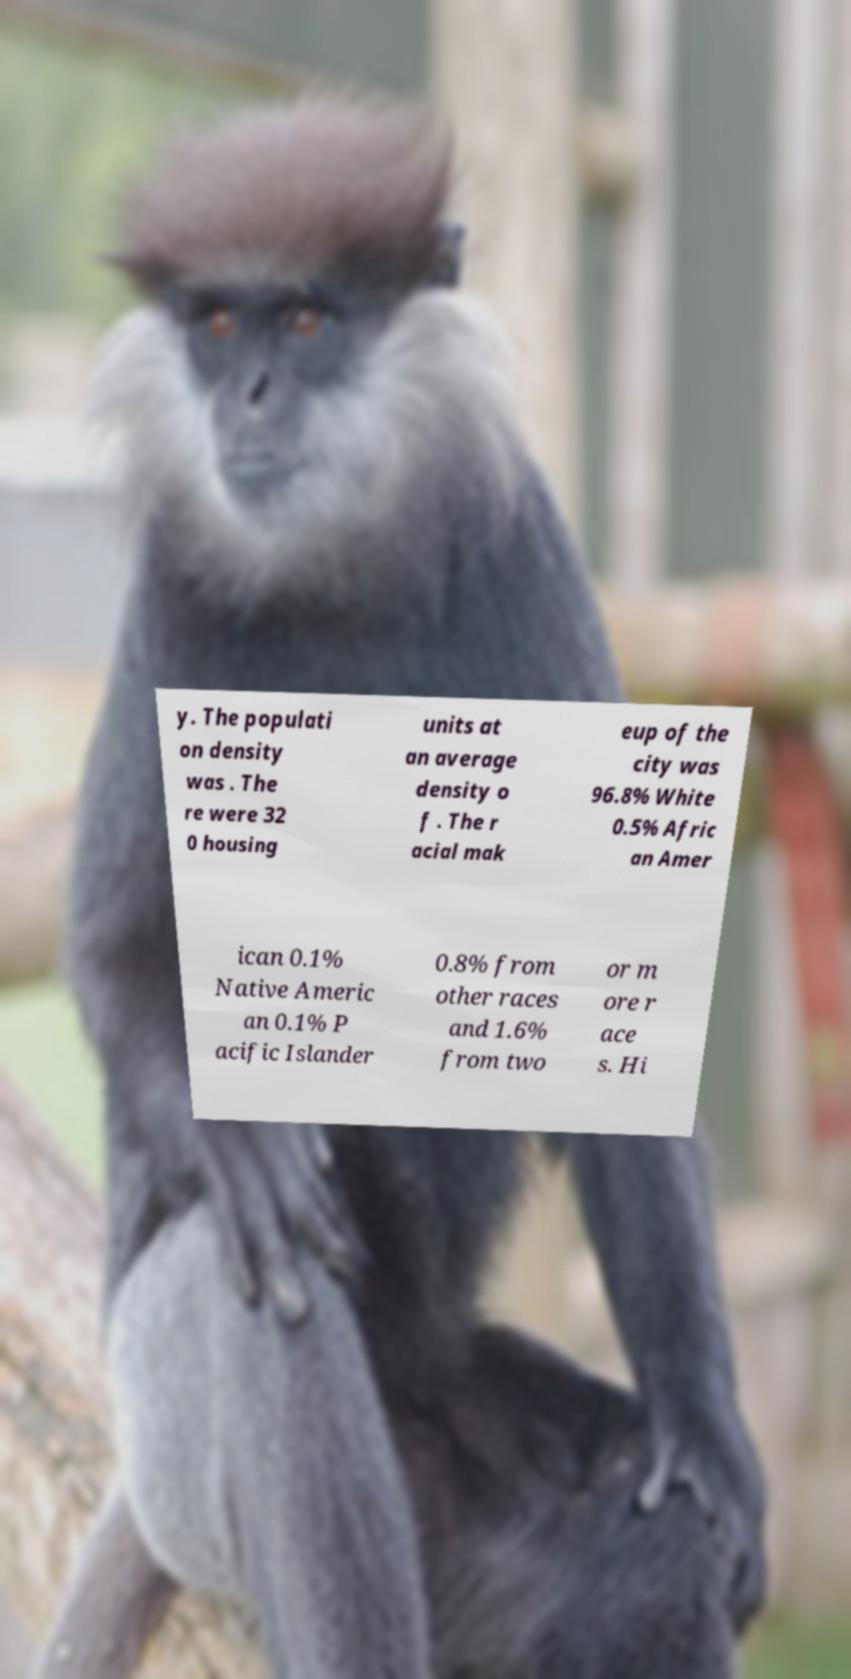Please read and relay the text visible in this image. What does it say? y. The populati on density was . The re were 32 0 housing units at an average density o f . The r acial mak eup of the city was 96.8% White 0.5% Afric an Amer ican 0.1% Native Americ an 0.1% P acific Islander 0.8% from other races and 1.6% from two or m ore r ace s. Hi 